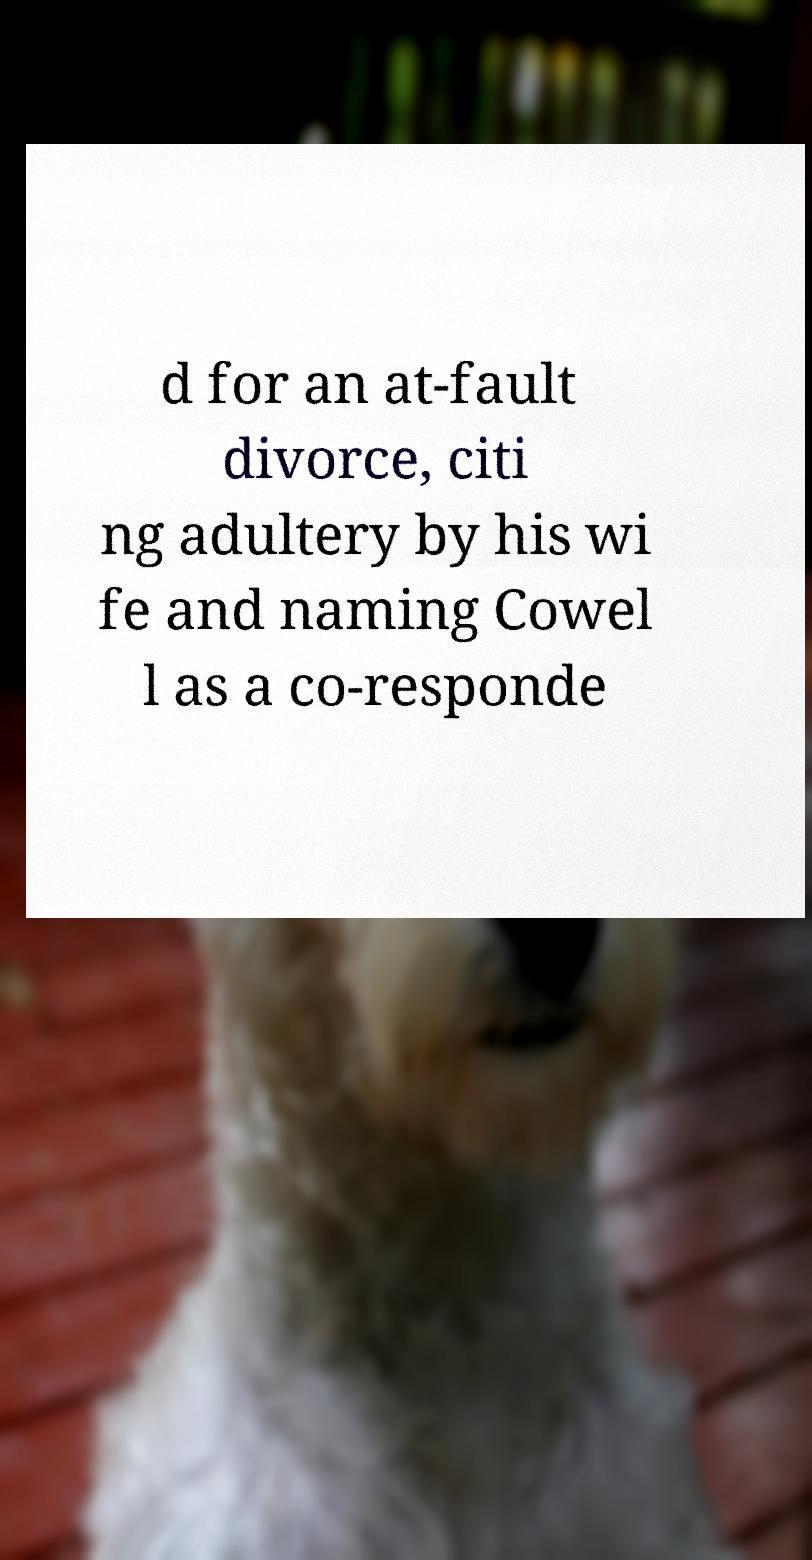Please read and relay the text visible in this image. What does it say? d for an at-fault divorce, citi ng adultery by his wi fe and naming Cowel l as a co-responde 